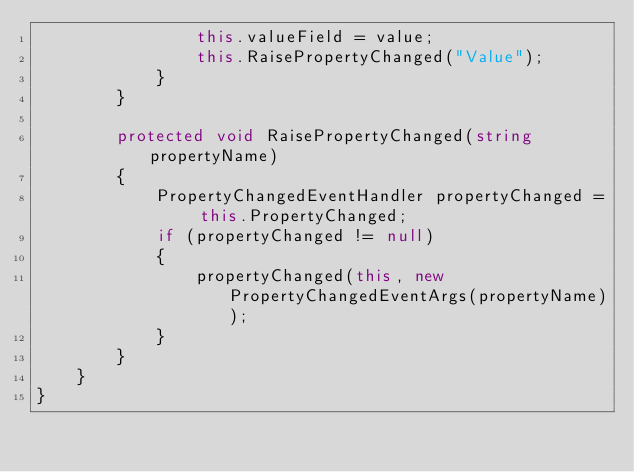<code> <loc_0><loc_0><loc_500><loc_500><_C#_>				this.valueField = value;
				this.RaisePropertyChanged("Value");
			}
		}

		protected void RaisePropertyChanged(string propertyName)
		{
			PropertyChangedEventHandler propertyChanged = this.PropertyChanged;
			if (propertyChanged != null)
			{
				propertyChanged(this, new PropertyChangedEventArgs(propertyName));
			}
		}
	}
}
</code> 